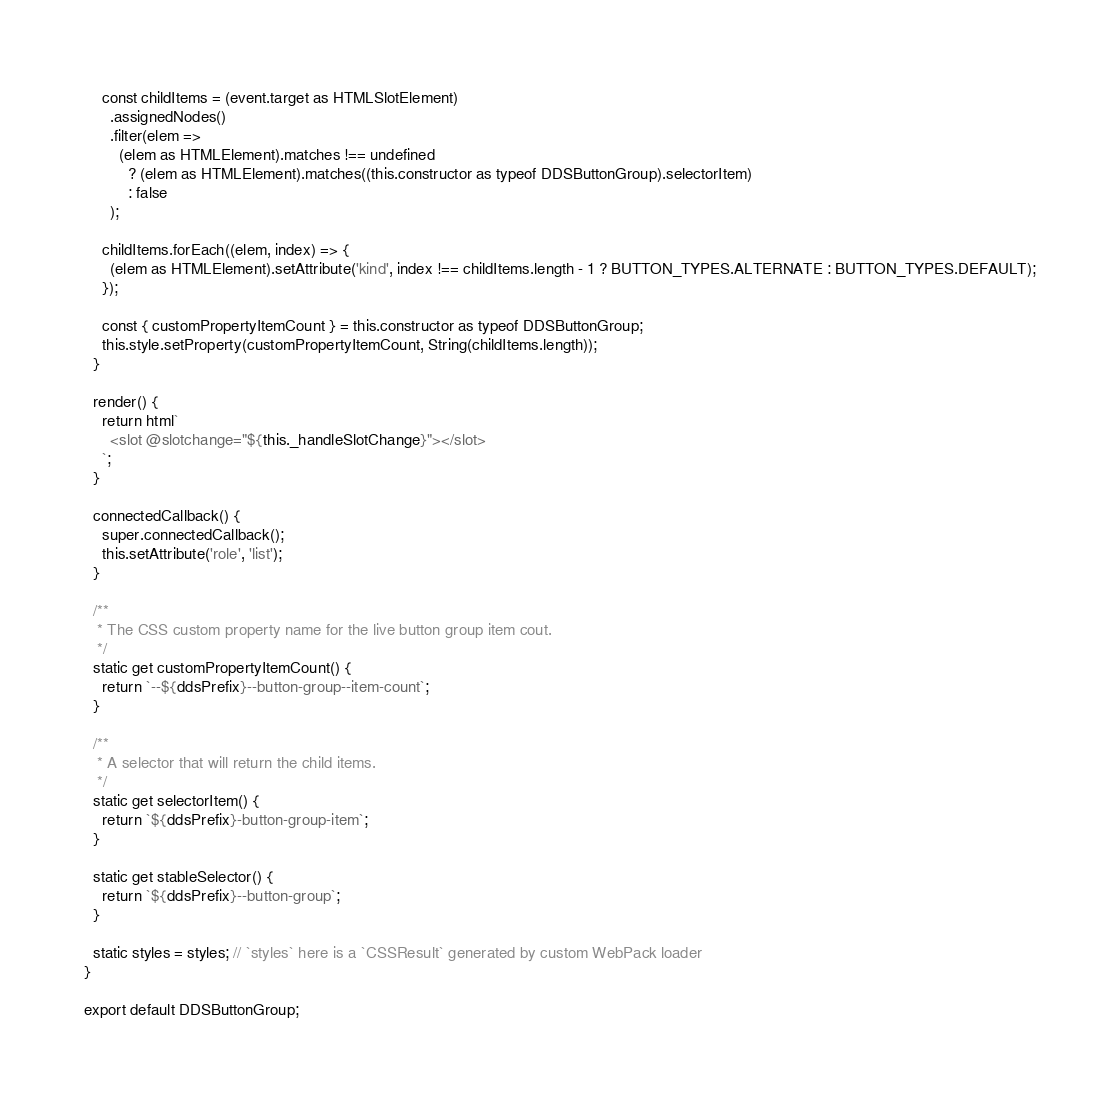<code> <loc_0><loc_0><loc_500><loc_500><_TypeScript_>    const childItems = (event.target as HTMLSlotElement)
      .assignedNodes()
      .filter(elem =>
        (elem as HTMLElement).matches !== undefined
          ? (elem as HTMLElement).matches((this.constructor as typeof DDSButtonGroup).selectorItem)
          : false
      );

    childItems.forEach((elem, index) => {
      (elem as HTMLElement).setAttribute('kind', index !== childItems.length - 1 ? BUTTON_TYPES.ALTERNATE : BUTTON_TYPES.DEFAULT);
    });

    const { customPropertyItemCount } = this.constructor as typeof DDSButtonGroup;
    this.style.setProperty(customPropertyItemCount, String(childItems.length));
  }

  render() {
    return html`
      <slot @slotchange="${this._handleSlotChange}"></slot>
    `;
  }

  connectedCallback() {
    super.connectedCallback();
    this.setAttribute('role', 'list');
  }

  /**
   * The CSS custom property name for the live button group item cout.
   */
  static get customPropertyItemCount() {
    return `--${ddsPrefix}--button-group--item-count`;
  }

  /**
   * A selector that will return the child items.
   */
  static get selectorItem() {
    return `${ddsPrefix}-button-group-item`;
  }

  static get stableSelector() {
    return `${ddsPrefix}--button-group`;
  }

  static styles = styles; // `styles` here is a `CSSResult` generated by custom WebPack loader
}

export default DDSButtonGroup;
</code> 